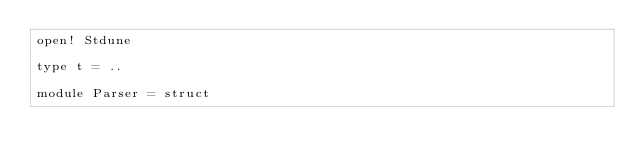<code> <loc_0><loc_0><loc_500><loc_500><_OCaml_>open! Stdune

type t = ..

module Parser = struct</code> 